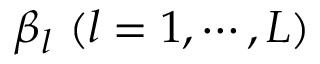Convert formula to latex. <formula><loc_0><loc_0><loc_500><loc_500>\beta _ { l } \ ( l = 1 , \cdots , L )</formula> 